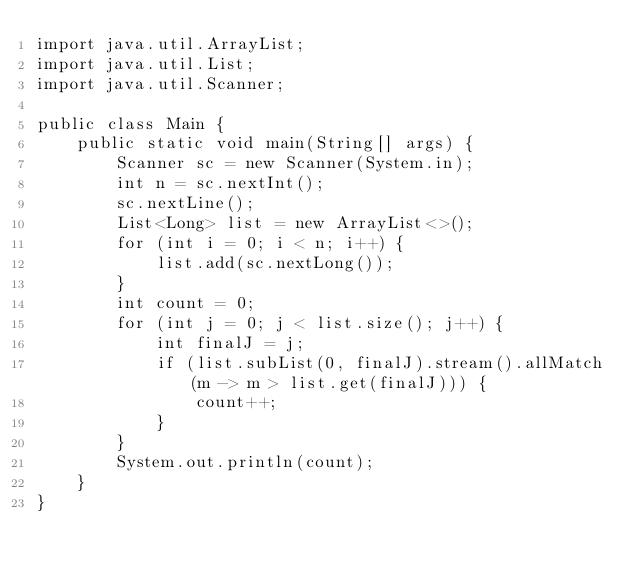Convert code to text. <code><loc_0><loc_0><loc_500><loc_500><_Java_>import java.util.ArrayList;
import java.util.List;
import java.util.Scanner;

public class Main {
    public static void main(String[] args) {
        Scanner sc = new Scanner(System.in);
        int n = sc.nextInt();
        sc.nextLine();
        List<Long> list = new ArrayList<>();
        for (int i = 0; i < n; i++) {
            list.add(sc.nextLong());
        }
        int count = 0;
        for (int j = 0; j < list.size(); j++) {
            int finalJ = j;
            if (list.subList(0, finalJ).stream().allMatch(m -> m > list.get(finalJ))) {
                count++;
            }
        }
        System.out.println(count);
    }
}
</code> 